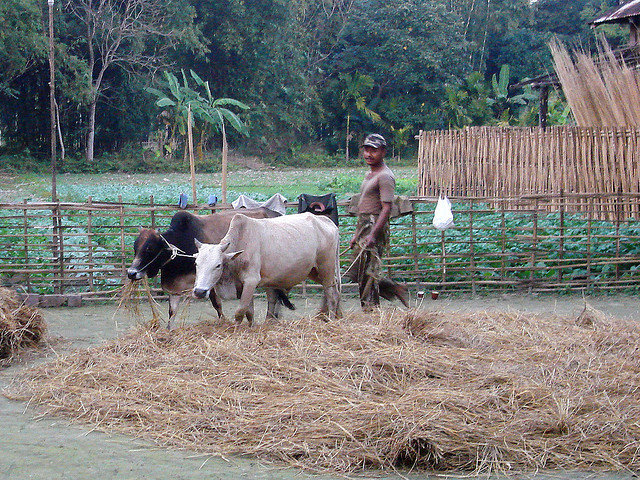What keeps the cattle from eating the garden here?
A. nothing
B. fear
C. man
D. fencing Option D, fencing, seems to be the most effective means of preventing the cattle from eating the garden. Based on what's observable in the image, there is a visible fence constructed with poles and other materials, creating a barrier between the garden and the grazing cattle. 